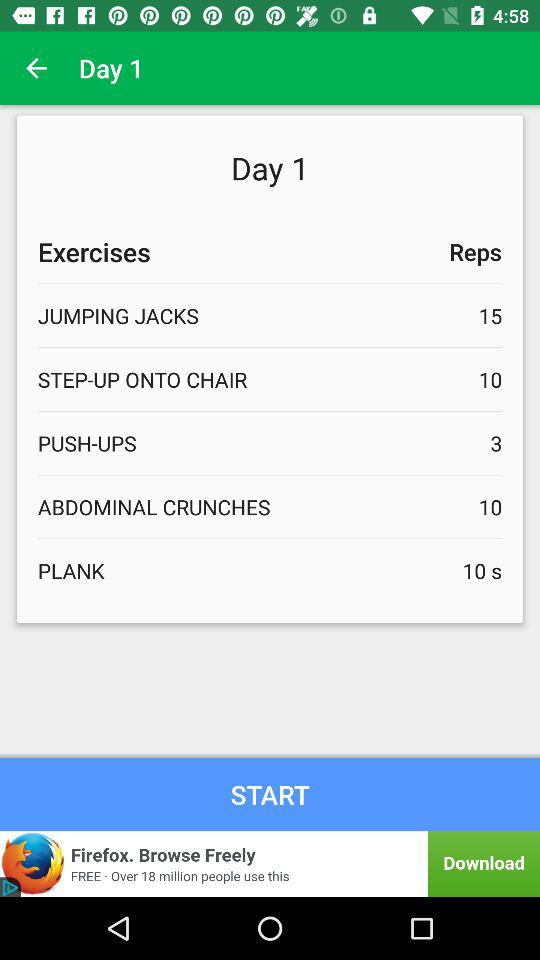On day 1, how many reps are there for "STEP-UP ONTO CHAIR"? There are 10 reps for "STEP-UP ONTO CHAIR" on Day 1. 